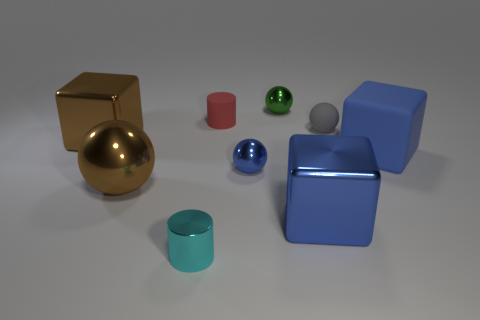What might be the size relationship between the cube and the sphere? If we compare the gold sphere and the larger blue cube, the cube appears to be roughly one and a half times wider than the diameter of the sphere, indicating a larger volume and size for the cube in comparison to the sphere. 